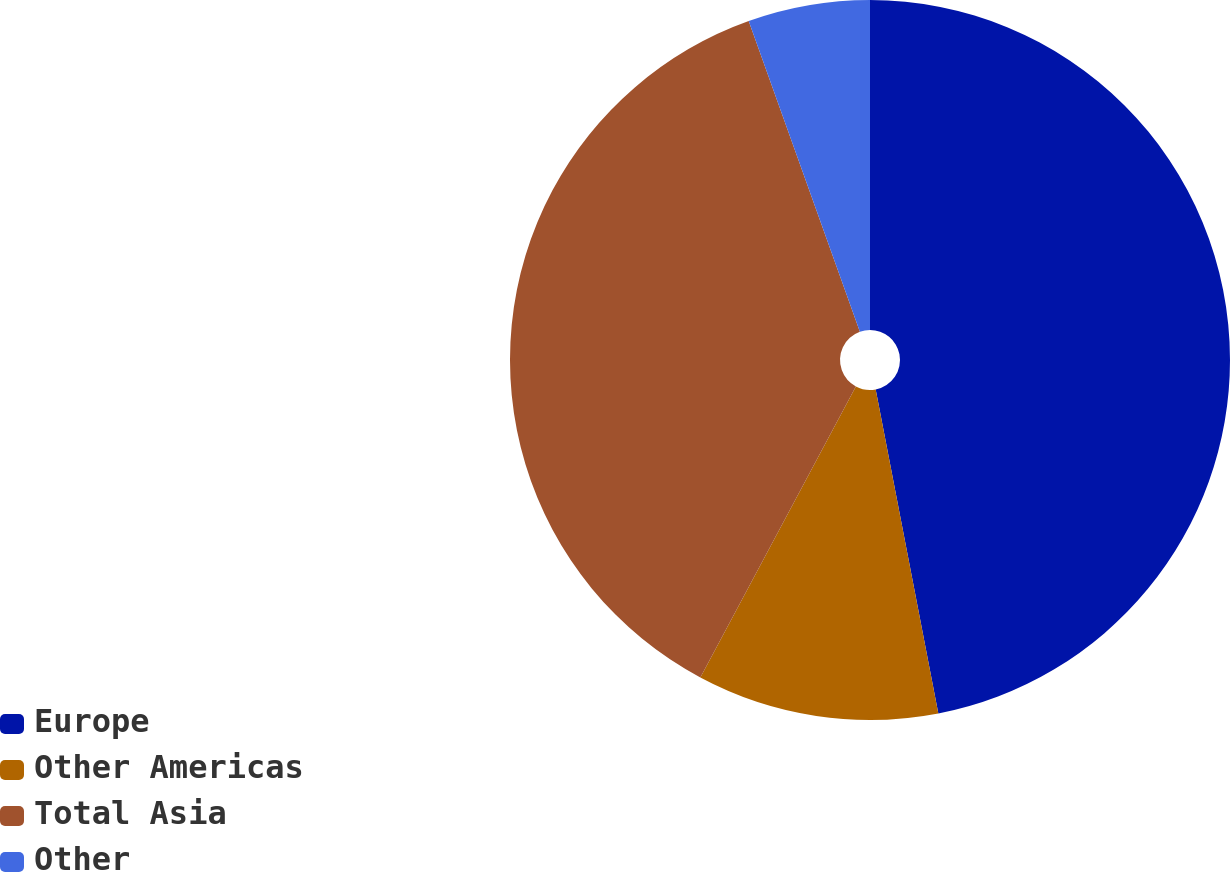Convert chart to OTSL. <chart><loc_0><loc_0><loc_500><loc_500><pie_chart><fcel>Europe<fcel>Other Americas<fcel>Total Asia<fcel>Other<nl><fcel>46.96%<fcel>10.85%<fcel>36.72%<fcel>5.47%<nl></chart> 